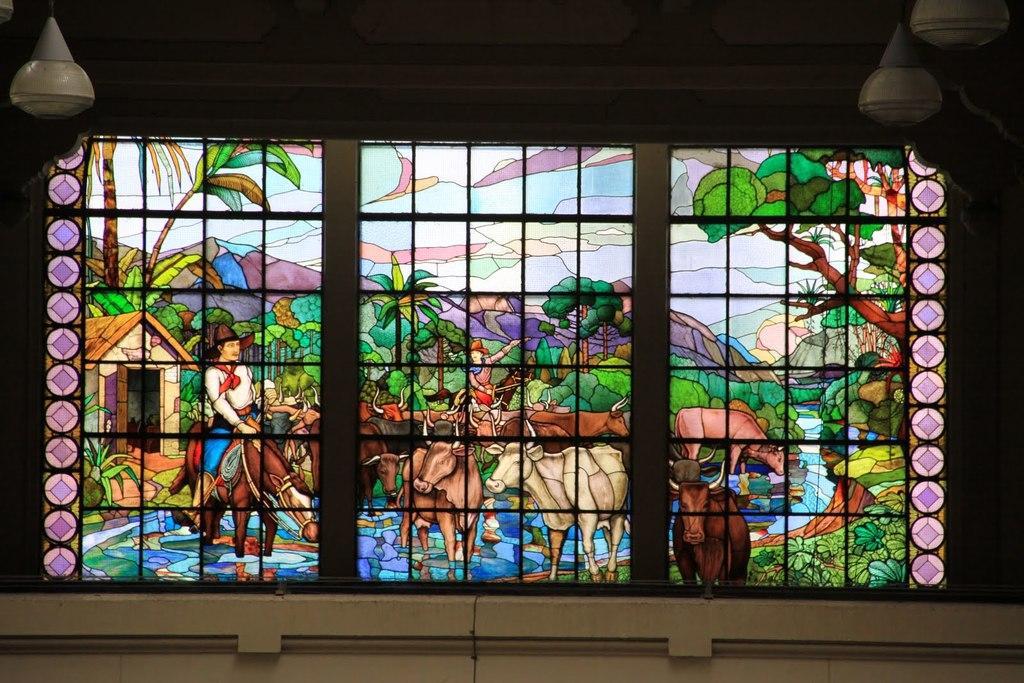Could you give a brief overview of what you see in this image? In this image we can see a stained glass window. At the top of the image there is ceiling and other objects. At the bottom of the image there is an object. 